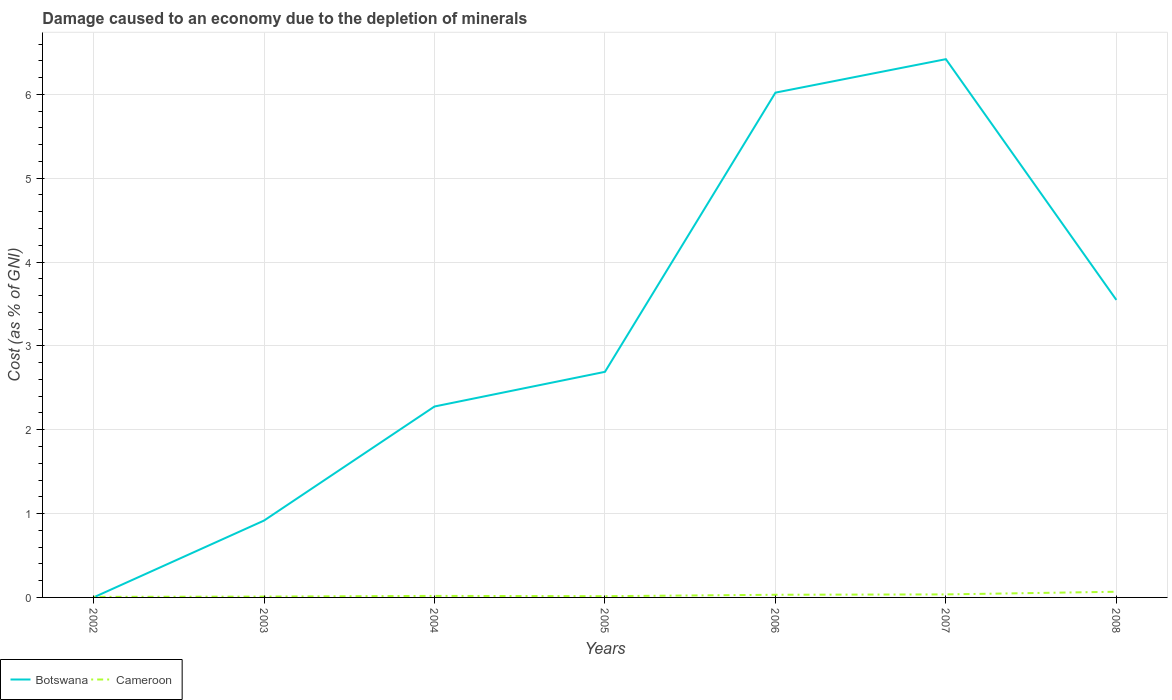Across all years, what is the maximum cost of damage caused due to the depletion of minerals in Cameroon?
Ensure brevity in your answer.  0.01. In which year was the cost of damage caused due to the depletion of minerals in Cameroon maximum?
Keep it short and to the point. 2002. What is the total cost of damage caused due to the depletion of minerals in Cameroon in the graph?
Provide a short and direct response. -0.03. What is the difference between the highest and the second highest cost of damage caused due to the depletion of minerals in Botswana?
Ensure brevity in your answer.  6.42. How many years are there in the graph?
Keep it short and to the point. 7. What is the difference between two consecutive major ticks on the Y-axis?
Give a very brief answer. 1. Does the graph contain any zero values?
Make the answer very short. No. Does the graph contain grids?
Offer a terse response. Yes. How many legend labels are there?
Give a very brief answer. 2. What is the title of the graph?
Your answer should be compact. Damage caused to an economy due to the depletion of minerals. Does "Belgium" appear as one of the legend labels in the graph?
Ensure brevity in your answer.  No. What is the label or title of the X-axis?
Your answer should be very brief. Years. What is the label or title of the Y-axis?
Your answer should be compact. Cost (as % of GNI). What is the Cost (as % of GNI) in Botswana in 2002?
Provide a short and direct response. 0. What is the Cost (as % of GNI) in Cameroon in 2002?
Your answer should be very brief. 0.01. What is the Cost (as % of GNI) in Botswana in 2003?
Ensure brevity in your answer.  0.92. What is the Cost (as % of GNI) of Cameroon in 2003?
Offer a terse response. 0.01. What is the Cost (as % of GNI) in Botswana in 2004?
Your answer should be very brief. 2.28. What is the Cost (as % of GNI) in Cameroon in 2004?
Provide a succinct answer. 0.02. What is the Cost (as % of GNI) of Botswana in 2005?
Keep it short and to the point. 2.69. What is the Cost (as % of GNI) of Cameroon in 2005?
Offer a very short reply. 0.01. What is the Cost (as % of GNI) in Botswana in 2006?
Offer a terse response. 6.02. What is the Cost (as % of GNI) of Cameroon in 2006?
Your answer should be compact. 0.03. What is the Cost (as % of GNI) of Botswana in 2007?
Your answer should be very brief. 6.42. What is the Cost (as % of GNI) of Cameroon in 2007?
Your response must be concise. 0.04. What is the Cost (as % of GNI) of Botswana in 2008?
Provide a succinct answer. 3.55. What is the Cost (as % of GNI) of Cameroon in 2008?
Keep it short and to the point. 0.07. Across all years, what is the maximum Cost (as % of GNI) in Botswana?
Ensure brevity in your answer.  6.42. Across all years, what is the maximum Cost (as % of GNI) in Cameroon?
Ensure brevity in your answer.  0.07. Across all years, what is the minimum Cost (as % of GNI) of Botswana?
Keep it short and to the point. 0. Across all years, what is the minimum Cost (as % of GNI) in Cameroon?
Keep it short and to the point. 0.01. What is the total Cost (as % of GNI) of Botswana in the graph?
Make the answer very short. 21.87. What is the total Cost (as % of GNI) in Cameroon in the graph?
Make the answer very short. 0.19. What is the difference between the Cost (as % of GNI) of Botswana in 2002 and that in 2003?
Keep it short and to the point. -0.92. What is the difference between the Cost (as % of GNI) in Cameroon in 2002 and that in 2003?
Ensure brevity in your answer.  -0. What is the difference between the Cost (as % of GNI) of Botswana in 2002 and that in 2004?
Offer a very short reply. -2.28. What is the difference between the Cost (as % of GNI) in Cameroon in 2002 and that in 2004?
Your answer should be very brief. -0.01. What is the difference between the Cost (as % of GNI) of Botswana in 2002 and that in 2005?
Keep it short and to the point. -2.69. What is the difference between the Cost (as % of GNI) of Cameroon in 2002 and that in 2005?
Your answer should be compact. -0.01. What is the difference between the Cost (as % of GNI) of Botswana in 2002 and that in 2006?
Provide a succinct answer. -6.02. What is the difference between the Cost (as % of GNI) of Cameroon in 2002 and that in 2006?
Keep it short and to the point. -0.03. What is the difference between the Cost (as % of GNI) of Botswana in 2002 and that in 2007?
Provide a succinct answer. -6.42. What is the difference between the Cost (as % of GNI) of Cameroon in 2002 and that in 2007?
Your answer should be very brief. -0.03. What is the difference between the Cost (as % of GNI) of Botswana in 2002 and that in 2008?
Offer a terse response. -3.55. What is the difference between the Cost (as % of GNI) of Cameroon in 2002 and that in 2008?
Offer a very short reply. -0.06. What is the difference between the Cost (as % of GNI) in Botswana in 2003 and that in 2004?
Offer a terse response. -1.36. What is the difference between the Cost (as % of GNI) of Cameroon in 2003 and that in 2004?
Your answer should be very brief. -0.01. What is the difference between the Cost (as % of GNI) in Botswana in 2003 and that in 2005?
Ensure brevity in your answer.  -1.77. What is the difference between the Cost (as % of GNI) in Cameroon in 2003 and that in 2005?
Provide a short and direct response. -0. What is the difference between the Cost (as % of GNI) of Botswana in 2003 and that in 2006?
Offer a very short reply. -5.1. What is the difference between the Cost (as % of GNI) of Cameroon in 2003 and that in 2006?
Your response must be concise. -0.02. What is the difference between the Cost (as % of GNI) in Botswana in 2003 and that in 2007?
Offer a terse response. -5.5. What is the difference between the Cost (as % of GNI) of Cameroon in 2003 and that in 2007?
Ensure brevity in your answer.  -0.03. What is the difference between the Cost (as % of GNI) in Botswana in 2003 and that in 2008?
Provide a short and direct response. -2.63. What is the difference between the Cost (as % of GNI) in Cameroon in 2003 and that in 2008?
Ensure brevity in your answer.  -0.06. What is the difference between the Cost (as % of GNI) of Botswana in 2004 and that in 2005?
Your response must be concise. -0.41. What is the difference between the Cost (as % of GNI) of Cameroon in 2004 and that in 2005?
Your answer should be compact. 0. What is the difference between the Cost (as % of GNI) in Botswana in 2004 and that in 2006?
Keep it short and to the point. -3.74. What is the difference between the Cost (as % of GNI) in Cameroon in 2004 and that in 2006?
Your response must be concise. -0.01. What is the difference between the Cost (as % of GNI) of Botswana in 2004 and that in 2007?
Provide a succinct answer. -4.14. What is the difference between the Cost (as % of GNI) of Cameroon in 2004 and that in 2007?
Ensure brevity in your answer.  -0.02. What is the difference between the Cost (as % of GNI) of Botswana in 2004 and that in 2008?
Offer a terse response. -1.27. What is the difference between the Cost (as % of GNI) of Cameroon in 2004 and that in 2008?
Provide a short and direct response. -0.05. What is the difference between the Cost (as % of GNI) of Botswana in 2005 and that in 2006?
Your answer should be compact. -3.33. What is the difference between the Cost (as % of GNI) in Cameroon in 2005 and that in 2006?
Your answer should be compact. -0.02. What is the difference between the Cost (as % of GNI) of Botswana in 2005 and that in 2007?
Provide a short and direct response. -3.73. What is the difference between the Cost (as % of GNI) in Cameroon in 2005 and that in 2007?
Provide a succinct answer. -0.02. What is the difference between the Cost (as % of GNI) in Botswana in 2005 and that in 2008?
Offer a terse response. -0.86. What is the difference between the Cost (as % of GNI) in Cameroon in 2005 and that in 2008?
Give a very brief answer. -0.05. What is the difference between the Cost (as % of GNI) in Botswana in 2006 and that in 2007?
Your answer should be very brief. -0.4. What is the difference between the Cost (as % of GNI) of Cameroon in 2006 and that in 2007?
Keep it short and to the point. -0. What is the difference between the Cost (as % of GNI) in Botswana in 2006 and that in 2008?
Your answer should be very brief. 2.47. What is the difference between the Cost (as % of GNI) of Cameroon in 2006 and that in 2008?
Provide a succinct answer. -0.04. What is the difference between the Cost (as % of GNI) of Botswana in 2007 and that in 2008?
Offer a terse response. 2.87. What is the difference between the Cost (as % of GNI) in Cameroon in 2007 and that in 2008?
Offer a terse response. -0.03. What is the difference between the Cost (as % of GNI) in Botswana in 2002 and the Cost (as % of GNI) in Cameroon in 2003?
Keep it short and to the point. -0.01. What is the difference between the Cost (as % of GNI) of Botswana in 2002 and the Cost (as % of GNI) of Cameroon in 2004?
Provide a short and direct response. -0.02. What is the difference between the Cost (as % of GNI) in Botswana in 2002 and the Cost (as % of GNI) in Cameroon in 2005?
Your answer should be compact. -0.01. What is the difference between the Cost (as % of GNI) in Botswana in 2002 and the Cost (as % of GNI) in Cameroon in 2006?
Keep it short and to the point. -0.03. What is the difference between the Cost (as % of GNI) in Botswana in 2002 and the Cost (as % of GNI) in Cameroon in 2007?
Ensure brevity in your answer.  -0.04. What is the difference between the Cost (as % of GNI) of Botswana in 2002 and the Cost (as % of GNI) of Cameroon in 2008?
Your answer should be very brief. -0.07. What is the difference between the Cost (as % of GNI) of Botswana in 2003 and the Cost (as % of GNI) of Cameroon in 2004?
Provide a succinct answer. 0.9. What is the difference between the Cost (as % of GNI) of Botswana in 2003 and the Cost (as % of GNI) of Cameroon in 2005?
Your answer should be compact. 0.9. What is the difference between the Cost (as % of GNI) in Botswana in 2003 and the Cost (as % of GNI) in Cameroon in 2006?
Keep it short and to the point. 0.88. What is the difference between the Cost (as % of GNI) in Botswana in 2003 and the Cost (as % of GNI) in Cameroon in 2007?
Give a very brief answer. 0.88. What is the difference between the Cost (as % of GNI) in Botswana in 2003 and the Cost (as % of GNI) in Cameroon in 2008?
Offer a terse response. 0.85. What is the difference between the Cost (as % of GNI) of Botswana in 2004 and the Cost (as % of GNI) of Cameroon in 2005?
Offer a terse response. 2.26. What is the difference between the Cost (as % of GNI) of Botswana in 2004 and the Cost (as % of GNI) of Cameroon in 2006?
Ensure brevity in your answer.  2.25. What is the difference between the Cost (as % of GNI) of Botswana in 2004 and the Cost (as % of GNI) of Cameroon in 2007?
Your answer should be compact. 2.24. What is the difference between the Cost (as % of GNI) of Botswana in 2004 and the Cost (as % of GNI) of Cameroon in 2008?
Give a very brief answer. 2.21. What is the difference between the Cost (as % of GNI) of Botswana in 2005 and the Cost (as % of GNI) of Cameroon in 2006?
Make the answer very short. 2.66. What is the difference between the Cost (as % of GNI) of Botswana in 2005 and the Cost (as % of GNI) of Cameroon in 2007?
Your response must be concise. 2.65. What is the difference between the Cost (as % of GNI) of Botswana in 2005 and the Cost (as % of GNI) of Cameroon in 2008?
Provide a short and direct response. 2.62. What is the difference between the Cost (as % of GNI) in Botswana in 2006 and the Cost (as % of GNI) in Cameroon in 2007?
Your answer should be very brief. 5.98. What is the difference between the Cost (as % of GNI) in Botswana in 2006 and the Cost (as % of GNI) in Cameroon in 2008?
Offer a very short reply. 5.95. What is the difference between the Cost (as % of GNI) of Botswana in 2007 and the Cost (as % of GNI) of Cameroon in 2008?
Keep it short and to the point. 6.35. What is the average Cost (as % of GNI) in Botswana per year?
Provide a short and direct response. 3.12. What is the average Cost (as % of GNI) of Cameroon per year?
Keep it short and to the point. 0.03. In the year 2002, what is the difference between the Cost (as % of GNI) in Botswana and Cost (as % of GNI) in Cameroon?
Provide a succinct answer. -0.01. In the year 2003, what is the difference between the Cost (as % of GNI) of Botswana and Cost (as % of GNI) of Cameroon?
Your answer should be very brief. 0.91. In the year 2004, what is the difference between the Cost (as % of GNI) in Botswana and Cost (as % of GNI) in Cameroon?
Provide a succinct answer. 2.26. In the year 2005, what is the difference between the Cost (as % of GNI) of Botswana and Cost (as % of GNI) of Cameroon?
Offer a terse response. 2.68. In the year 2006, what is the difference between the Cost (as % of GNI) in Botswana and Cost (as % of GNI) in Cameroon?
Provide a short and direct response. 5.99. In the year 2007, what is the difference between the Cost (as % of GNI) in Botswana and Cost (as % of GNI) in Cameroon?
Your answer should be very brief. 6.38. In the year 2008, what is the difference between the Cost (as % of GNI) of Botswana and Cost (as % of GNI) of Cameroon?
Offer a terse response. 3.48. What is the ratio of the Cost (as % of GNI) of Cameroon in 2002 to that in 2003?
Your answer should be compact. 0.64. What is the ratio of the Cost (as % of GNI) of Botswana in 2002 to that in 2004?
Give a very brief answer. 0. What is the ratio of the Cost (as % of GNI) in Cameroon in 2002 to that in 2004?
Ensure brevity in your answer.  0.36. What is the ratio of the Cost (as % of GNI) of Botswana in 2002 to that in 2005?
Provide a succinct answer. 0. What is the ratio of the Cost (as % of GNI) in Cameroon in 2002 to that in 2005?
Ensure brevity in your answer.  0.44. What is the ratio of the Cost (as % of GNI) of Cameroon in 2002 to that in 2006?
Your response must be concise. 0.21. What is the ratio of the Cost (as % of GNI) in Botswana in 2002 to that in 2007?
Provide a short and direct response. 0. What is the ratio of the Cost (as % of GNI) of Cameroon in 2002 to that in 2007?
Make the answer very short. 0.18. What is the ratio of the Cost (as % of GNI) of Cameroon in 2002 to that in 2008?
Your answer should be very brief. 0.1. What is the ratio of the Cost (as % of GNI) of Botswana in 2003 to that in 2004?
Make the answer very short. 0.4. What is the ratio of the Cost (as % of GNI) of Cameroon in 2003 to that in 2004?
Provide a short and direct response. 0.56. What is the ratio of the Cost (as % of GNI) in Botswana in 2003 to that in 2005?
Your answer should be compact. 0.34. What is the ratio of the Cost (as % of GNI) in Cameroon in 2003 to that in 2005?
Your response must be concise. 0.69. What is the ratio of the Cost (as % of GNI) in Botswana in 2003 to that in 2006?
Your response must be concise. 0.15. What is the ratio of the Cost (as % of GNI) in Cameroon in 2003 to that in 2006?
Your answer should be very brief. 0.32. What is the ratio of the Cost (as % of GNI) in Botswana in 2003 to that in 2007?
Give a very brief answer. 0.14. What is the ratio of the Cost (as % of GNI) in Cameroon in 2003 to that in 2007?
Offer a very short reply. 0.29. What is the ratio of the Cost (as % of GNI) of Botswana in 2003 to that in 2008?
Keep it short and to the point. 0.26. What is the ratio of the Cost (as % of GNI) in Cameroon in 2003 to that in 2008?
Provide a succinct answer. 0.15. What is the ratio of the Cost (as % of GNI) in Botswana in 2004 to that in 2005?
Make the answer very short. 0.85. What is the ratio of the Cost (as % of GNI) in Cameroon in 2004 to that in 2005?
Your answer should be compact. 1.23. What is the ratio of the Cost (as % of GNI) in Botswana in 2004 to that in 2006?
Ensure brevity in your answer.  0.38. What is the ratio of the Cost (as % of GNI) of Cameroon in 2004 to that in 2006?
Make the answer very short. 0.57. What is the ratio of the Cost (as % of GNI) of Botswana in 2004 to that in 2007?
Keep it short and to the point. 0.35. What is the ratio of the Cost (as % of GNI) of Cameroon in 2004 to that in 2007?
Your answer should be compact. 0.51. What is the ratio of the Cost (as % of GNI) of Botswana in 2004 to that in 2008?
Give a very brief answer. 0.64. What is the ratio of the Cost (as % of GNI) of Cameroon in 2004 to that in 2008?
Give a very brief answer. 0.27. What is the ratio of the Cost (as % of GNI) in Botswana in 2005 to that in 2006?
Your response must be concise. 0.45. What is the ratio of the Cost (as % of GNI) in Cameroon in 2005 to that in 2006?
Your response must be concise. 0.47. What is the ratio of the Cost (as % of GNI) in Botswana in 2005 to that in 2007?
Give a very brief answer. 0.42. What is the ratio of the Cost (as % of GNI) in Cameroon in 2005 to that in 2007?
Provide a succinct answer. 0.41. What is the ratio of the Cost (as % of GNI) in Botswana in 2005 to that in 2008?
Make the answer very short. 0.76. What is the ratio of the Cost (as % of GNI) of Cameroon in 2005 to that in 2008?
Ensure brevity in your answer.  0.22. What is the ratio of the Cost (as % of GNI) of Botswana in 2006 to that in 2007?
Make the answer very short. 0.94. What is the ratio of the Cost (as % of GNI) in Cameroon in 2006 to that in 2007?
Provide a short and direct response. 0.88. What is the ratio of the Cost (as % of GNI) of Botswana in 2006 to that in 2008?
Your answer should be very brief. 1.7. What is the ratio of the Cost (as % of GNI) of Cameroon in 2006 to that in 2008?
Make the answer very short. 0.47. What is the ratio of the Cost (as % of GNI) in Botswana in 2007 to that in 2008?
Ensure brevity in your answer.  1.81. What is the ratio of the Cost (as % of GNI) of Cameroon in 2007 to that in 2008?
Your answer should be compact. 0.53. What is the difference between the highest and the second highest Cost (as % of GNI) in Botswana?
Provide a succinct answer. 0.4. What is the difference between the highest and the second highest Cost (as % of GNI) of Cameroon?
Ensure brevity in your answer.  0.03. What is the difference between the highest and the lowest Cost (as % of GNI) in Botswana?
Offer a terse response. 6.42. What is the difference between the highest and the lowest Cost (as % of GNI) of Cameroon?
Provide a short and direct response. 0.06. 